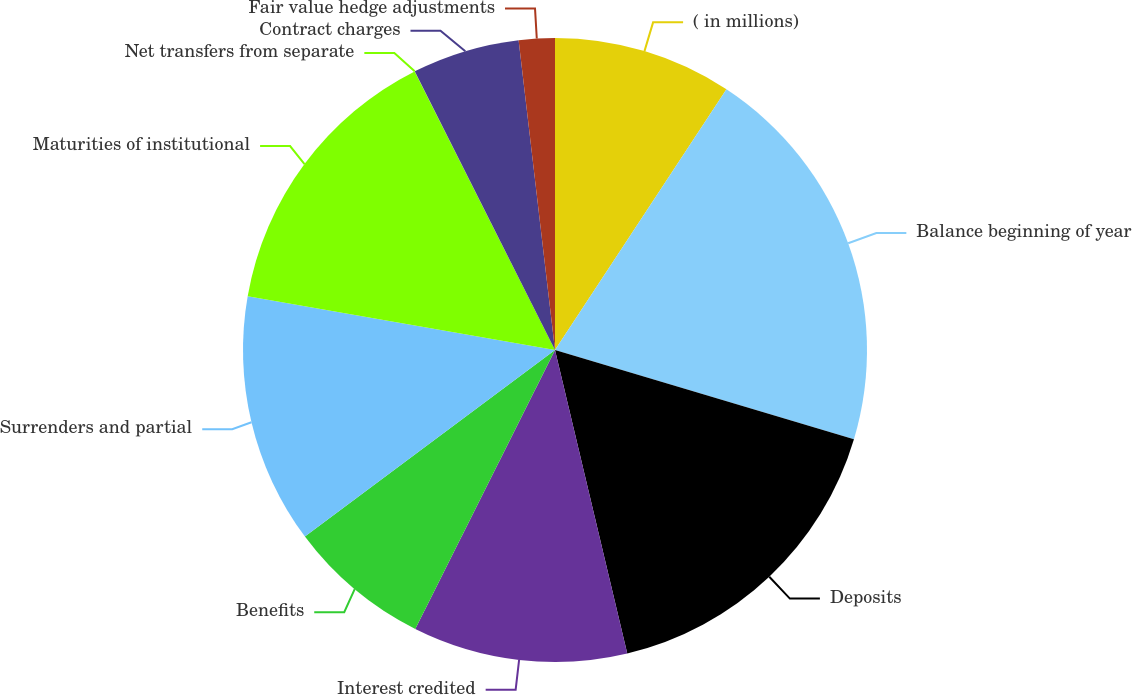Convert chart to OTSL. <chart><loc_0><loc_0><loc_500><loc_500><pie_chart><fcel>( in millions)<fcel>Balance beginning of year<fcel>Deposits<fcel>Interest credited<fcel>Benefits<fcel>Surrenders and partial<fcel>Maturities of institutional<fcel>Net transfers from separate<fcel>Contract charges<fcel>Fair value hedge adjustments<nl><fcel>9.26%<fcel>20.36%<fcel>16.66%<fcel>11.11%<fcel>7.41%<fcel>12.96%<fcel>14.81%<fcel>0.01%<fcel>5.56%<fcel>1.86%<nl></chart> 